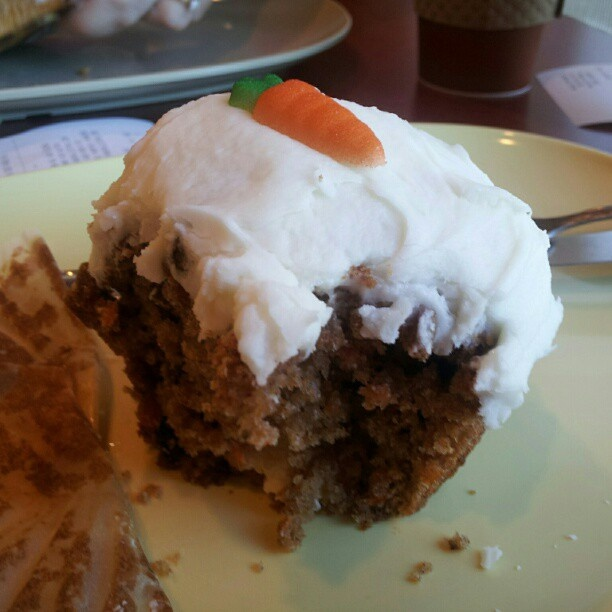Describe the objects in this image and their specific colors. I can see cake in gray, black, lightgray, darkgray, and maroon tones, dining table in gray, black, and maroon tones, cup in gray, black, and maroon tones, carrot in gray, brown, red, black, and salmon tones, and spoon in gray, black, and maroon tones in this image. 